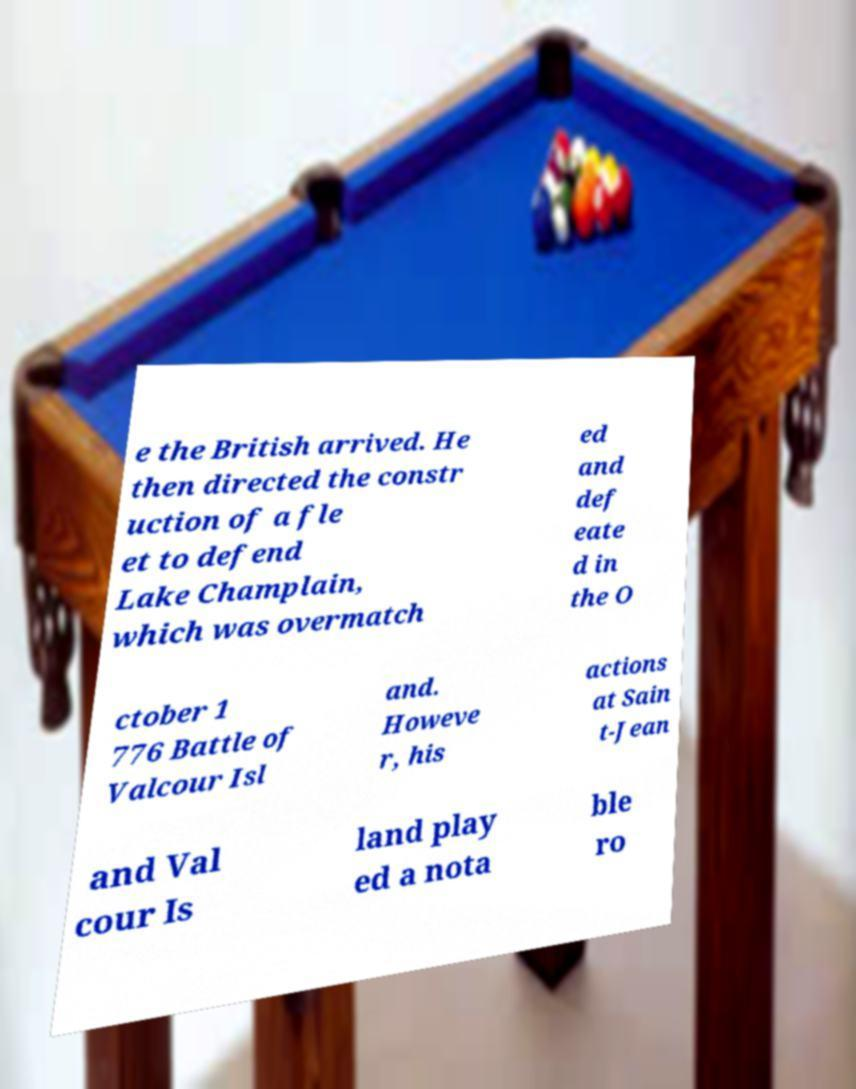Could you extract and type out the text from this image? e the British arrived. He then directed the constr uction of a fle et to defend Lake Champlain, which was overmatch ed and def eate d in the O ctober 1 776 Battle of Valcour Isl and. Howeve r, his actions at Sain t-Jean and Val cour Is land play ed a nota ble ro 